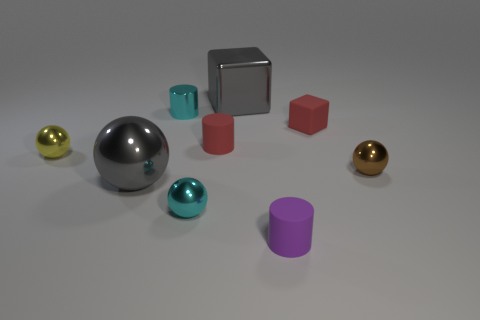Imagine if these objects are part of a game; how would you describe the gameplay? Envisioning these objects as part of a game, I'd say it could involve a sorting challenge where players must quickly categorize the objects by shape or color, possibly scoring points for speed and accuracy. 